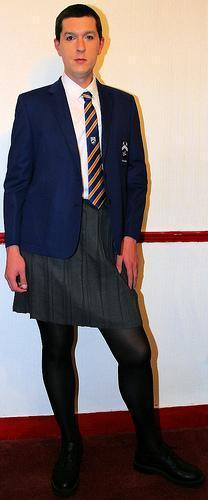How many people are there?
Give a very brief answer. 1. 